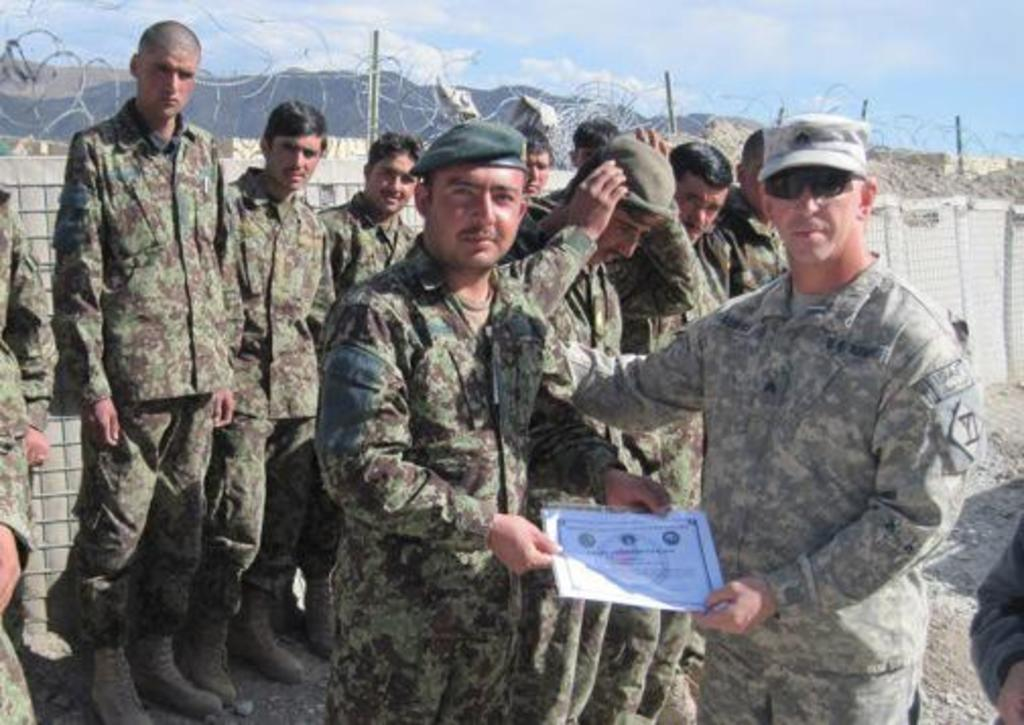How many people are present in the image? There are two people in the image. What are the two people holding in their hands? The two people are holding certificates in their hands. Can you describe the background of the image? There are people in the background of the image, and there is a fence visible. What type of popcorn is being served to the people in the image? There is no popcorn present in the image. Can you see an ant crawling on the fence in the background of the image? There is no ant visible in the image. 